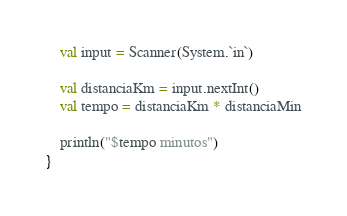Convert code to text. <code><loc_0><loc_0><loc_500><loc_500><_Kotlin_>    val input = Scanner(System.`in`)

    val distanciaKm = input.nextInt()
    val tempo = distanciaKm * distanciaMin

    println("$tempo minutos")
}</code> 